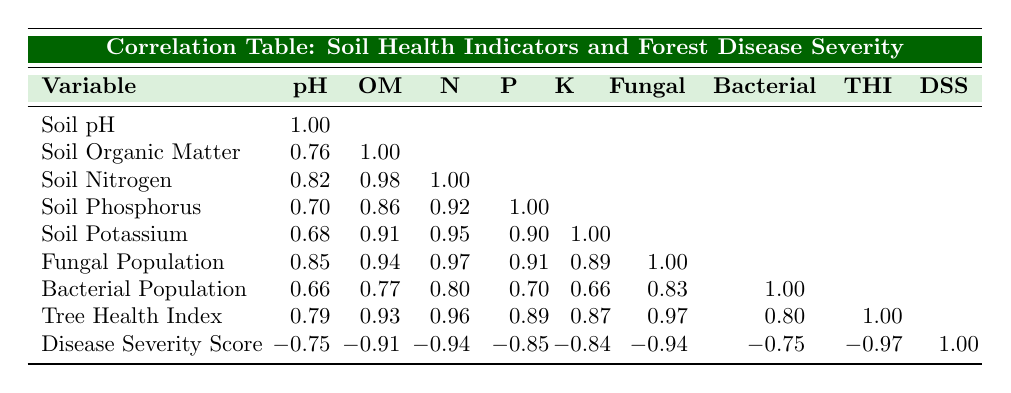What is the correlation between Soil pH and Disease Severity Score? Referring to the table, the correlation value between Soil pH and Disease Severity Score is -0.75.
Answer: -0.75 What is the highest value of Soil Organic Matter recorded in the table? Looking at the 'Soil Organic Matter' column, the values are 3.2, 4.5, 2.5, 5.0, and 3.8. The highest value is 5.0.
Answer: 5.0 Is the correlation between Tree Health Index and Disease Severity Score positive or negative? The correlation value between Tree Health Index and Disease Severity Score is -0.97, which indicates a negative correlation.
Answer: Negative What is the average Soil Nitrogen value across all observations? The Soil Nitrogen values are 0.15, 0.20, 0.10, 0.25, and 0.18. Summing them up gives 0.15 + 0.20 + 0.10 + 0.25 + 0.18 = 0.98. Dividing by 5 gives an average of 0.196.
Answer: 0.196 Which soil health indicator has the strongest correlation with Disease Severity Score? Assessing the correlation values in the table, the strongest correlation is between Disease Severity Score and Fungal Population, with a value of -0.94.
Answer: Fungal Population 